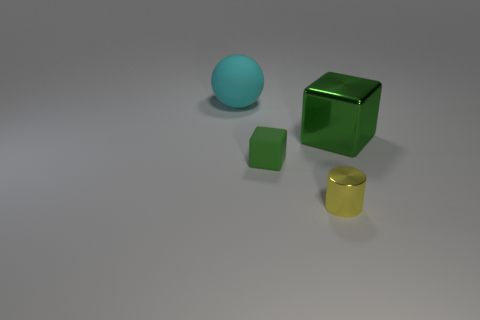There is a cyan rubber ball that is to the left of the metal thing that is right of the yellow cylinder; are there any cylinders that are right of it?
Offer a terse response. Yes. Are there fewer green metallic things that are in front of the yellow object than large metal objects?
Your response must be concise. Yes. What number of other things are the same shape as the big matte object?
Offer a terse response. 0. How many things are either shiny things behind the cylinder or large things right of the sphere?
Your answer should be compact. 1. There is a thing that is behind the small green matte thing and to the right of the cyan thing; how big is it?
Provide a succinct answer. Large. There is a big object that is on the left side of the big shiny block; is its shape the same as the big green object?
Give a very brief answer. No. What is the size of the cube that is to the left of the large thing that is to the right of the large thing to the left of the large green shiny thing?
Your response must be concise. Small. The metallic thing that is the same color as the matte block is what size?
Give a very brief answer. Large. How many things are big green spheres or tiny green rubber blocks?
Your response must be concise. 1. There is a object that is both behind the small green thing and to the left of the yellow metallic cylinder; what is its shape?
Offer a terse response. Sphere. 